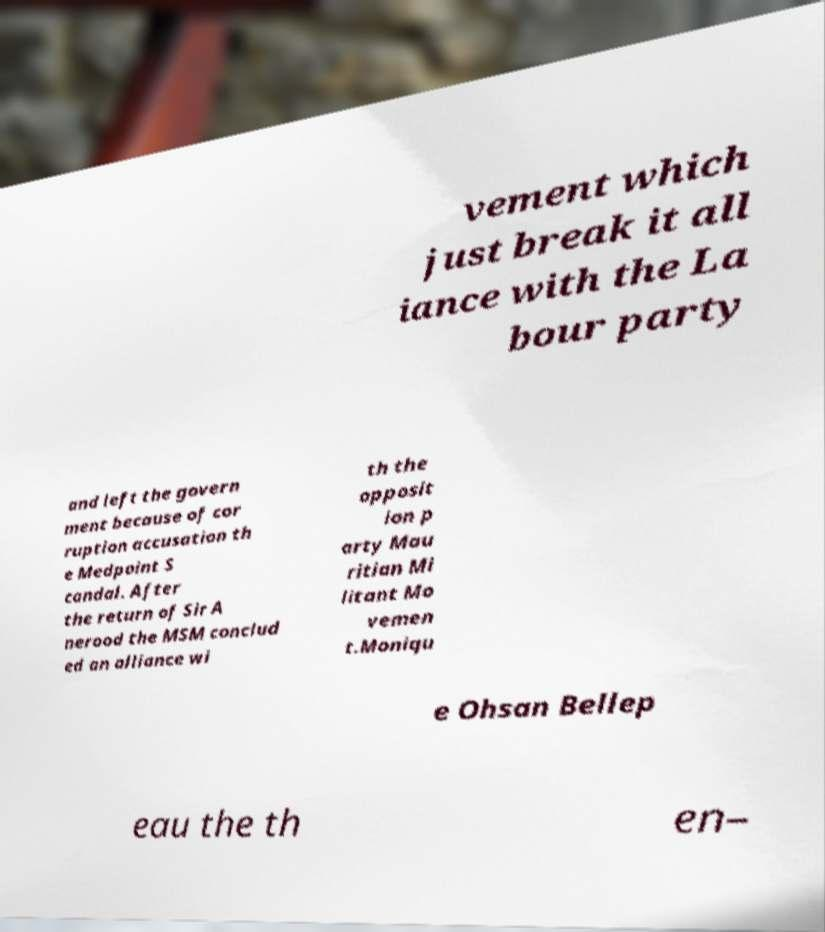Please identify and transcribe the text found in this image. vement which just break it all iance with the La bour party and left the govern ment because of cor ruption accusation th e Medpoint S candal. After the return of Sir A nerood the MSM conclud ed an alliance wi th the opposit ion p arty Mau ritian Mi litant Mo vemen t.Moniqu e Ohsan Bellep eau the th en– 